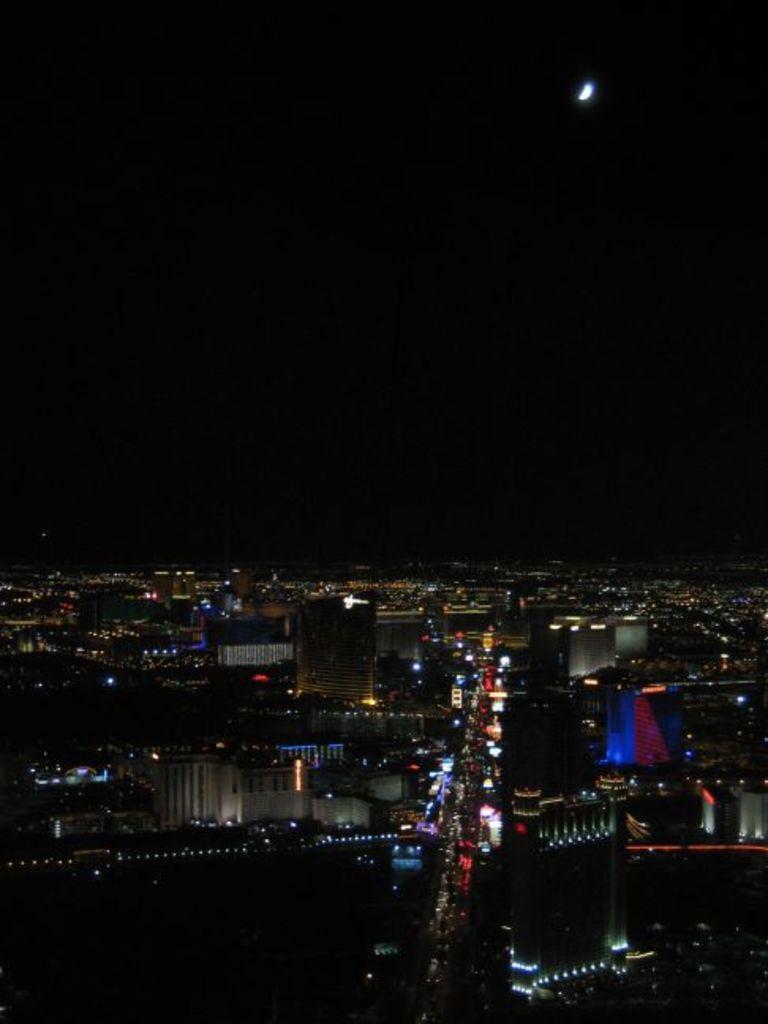In one or two sentences, can you explain what this image depicts? In this image I can see few buildings and I can also see few lights. In the background I can see the moon and the sky is in black color. 